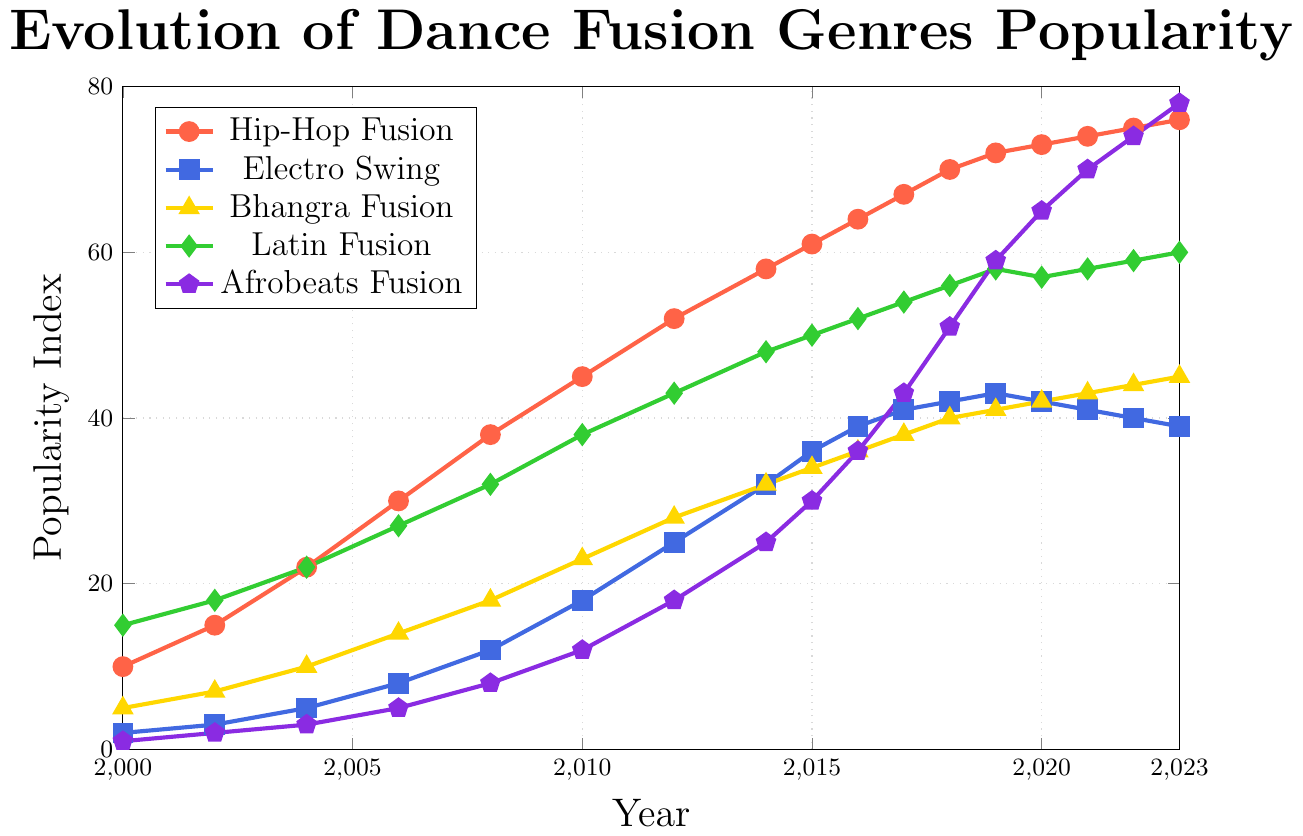What is the popularity index of Hip-Hop Fusion in 2010? Look for the value on the Hip-Hop Fusion line, which is marked by a red color, at the year 2010
Answer: 45 Which dance fusion genre saw the highest increase in popularity between 2000 and 2023? Compare the increase in popularity indices for each genre over the time period. Hip-Hop Fusion rose from 10 to 76, Electro Swing from 2 to 39, Bhangra Fusion from 5 to 45, Latin Fusion from 15 to 60, Afrobeats Fusion from 1 to 78. The highest increase is for Afrobeats Fusion
Answer: Afrobeats Fusion In which year did Electro Swing reach its peak popularity? Look for the highest point on the Electro Swing line, marked by a blue color. The peak value is 43, which occurs in 2019
Answer: 2019 What is the average popularity index of Latin Fusion from 2000 to 2004? Sum the popularity indices of Latin Fusion for the years 2000, 2002, and 2004, then divide by the number of years. (15 + 18 + 22) / 3 = 55 / 3 = approx. 18.33
Answer: approx. 18.33 How does the trend of Afrobeats Fusion popularity compare to that of Bhangra Fusion from 2010 to 2023? Compare the slope and direction of both lines from 2010 to 2023. Afrobeats Fusion shows a steeper and more consistent rise from 12 to 78, whereas Bhangra Fusion has a slower, steadier increase from 23 to 45
Answer: Afrobeats Fusion rises faster What is the difference in the popularity index between Hip-Hop Fusion and Electro Swing in 2023? Subtract the 2023 value of Electro Swing (39) from the value of Hip-Hop Fusion (76). 76 - 39 = 37
Answer: 37 Which two genres were closest in popularity in 2015? Compare the values for all genres in 2015. Hip-Hop Fusion: 61, Electro Swing: 36, Bhangra Fusion: 34, Latin Fusion: 50, Afrobeats Fusion: 30. Bhangra Fusion and Electro Swing are the closest, with values of 34 and 36 respectively
Answer: Bhangra Fusion and Electro Swing What is the median popularity index for all genres in 2020? Collect the 2020 values: Hip-Hop Fusion (73), Electro Swing (42), Bhangra Fusion (42), Latin Fusion (57), Afrobeats Fusion (65). Order them: 42, 42, 57, 65, 73. The middle value is 57
Answer: 57 Which genre showed a decline in popularity after 2020? Compare the values for each genre in 2020 and subsequent years. Electro Swing shows a decline from 42 in 2020 to 41, 40, and 39 in subsequent years
Answer: Electro Swing 